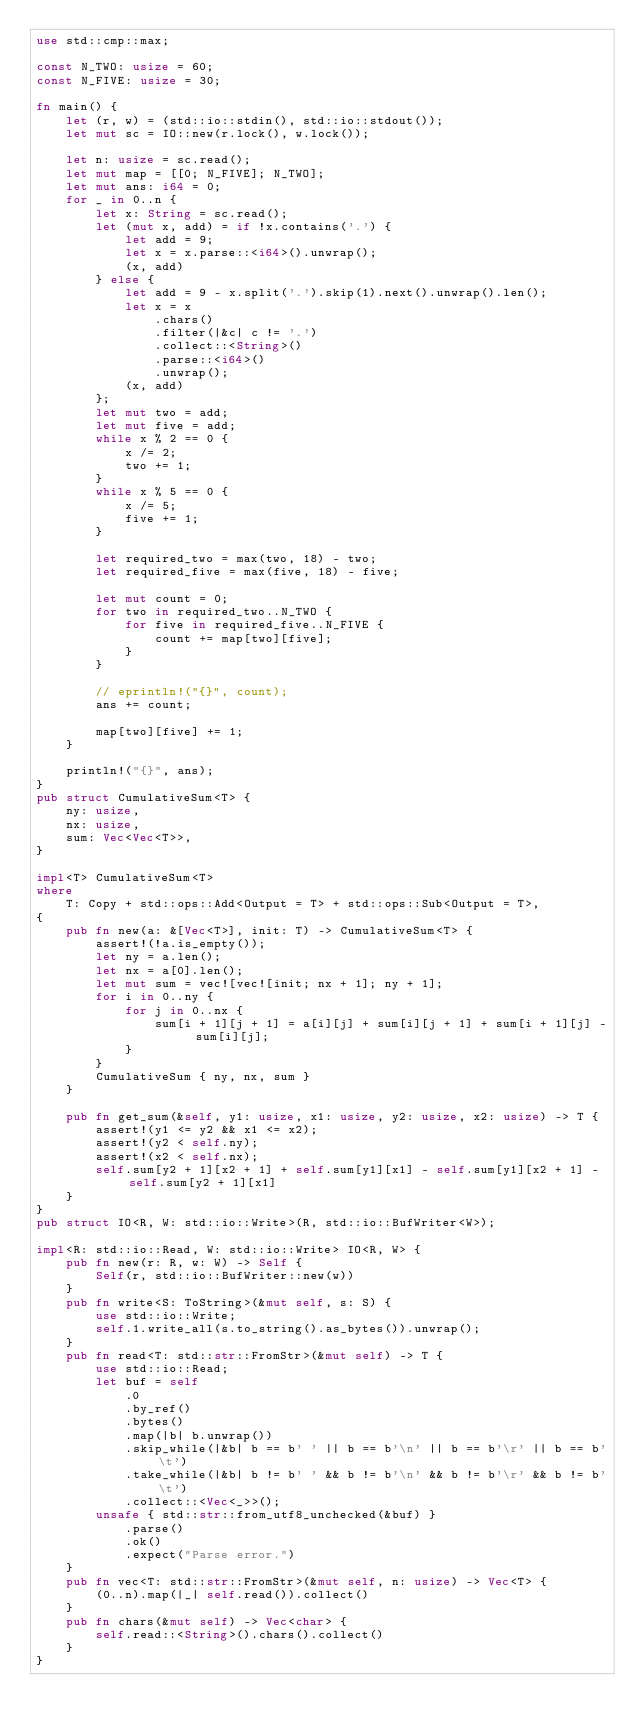Convert code to text. <code><loc_0><loc_0><loc_500><loc_500><_Rust_>use std::cmp::max;

const N_TWO: usize = 60;
const N_FIVE: usize = 30;

fn main() {
    let (r, w) = (std::io::stdin(), std::io::stdout());
    let mut sc = IO::new(r.lock(), w.lock());

    let n: usize = sc.read();
    let mut map = [[0; N_FIVE]; N_TWO];
    let mut ans: i64 = 0;
    for _ in 0..n {
        let x: String = sc.read();
        let (mut x, add) = if !x.contains('.') {
            let add = 9;
            let x = x.parse::<i64>().unwrap();
            (x, add)
        } else {
            let add = 9 - x.split('.').skip(1).next().unwrap().len();
            let x = x
                .chars()
                .filter(|&c| c != '.')
                .collect::<String>()
                .parse::<i64>()
                .unwrap();
            (x, add)
        };
        let mut two = add;
        let mut five = add;
        while x % 2 == 0 {
            x /= 2;
            two += 1;
        }
        while x % 5 == 0 {
            x /= 5;
            five += 1;
        }

        let required_two = max(two, 18) - two;
        let required_five = max(five, 18) - five;

        let mut count = 0;
        for two in required_two..N_TWO {
            for five in required_five..N_FIVE {
                count += map[two][five];
            }
        }

        // eprintln!("{}", count);
        ans += count;

        map[two][five] += 1;
    }

    println!("{}", ans);
}
pub struct CumulativeSum<T> {
    ny: usize,
    nx: usize,
    sum: Vec<Vec<T>>,
}

impl<T> CumulativeSum<T>
where
    T: Copy + std::ops::Add<Output = T> + std::ops::Sub<Output = T>,
{
    pub fn new(a: &[Vec<T>], init: T) -> CumulativeSum<T> {
        assert!(!a.is_empty());
        let ny = a.len();
        let nx = a[0].len();
        let mut sum = vec![vec![init; nx + 1]; ny + 1];
        for i in 0..ny {
            for j in 0..nx {
                sum[i + 1][j + 1] = a[i][j] + sum[i][j + 1] + sum[i + 1][j] - sum[i][j];
            }
        }
        CumulativeSum { ny, nx, sum }
    }

    pub fn get_sum(&self, y1: usize, x1: usize, y2: usize, x2: usize) -> T {
        assert!(y1 <= y2 && x1 <= x2);
        assert!(y2 < self.ny);
        assert!(x2 < self.nx);
        self.sum[y2 + 1][x2 + 1] + self.sum[y1][x1] - self.sum[y1][x2 + 1] - self.sum[y2 + 1][x1]
    }
}
pub struct IO<R, W: std::io::Write>(R, std::io::BufWriter<W>);

impl<R: std::io::Read, W: std::io::Write> IO<R, W> {
    pub fn new(r: R, w: W) -> Self {
        Self(r, std::io::BufWriter::new(w))
    }
    pub fn write<S: ToString>(&mut self, s: S) {
        use std::io::Write;
        self.1.write_all(s.to_string().as_bytes()).unwrap();
    }
    pub fn read<T: std::str::FromStr>(&mut self) -> T {
        use std::io::Read;
        let buf = self
            .0
            .by_ref()
            .bytes()
            .map(|b| b.unwrap())
            .skip_while(|&b| b == b' ' || b == b'\n' || b == b'\r' || b == b'\t')
            .take_while(|&b| b != b' ' && b != b'\n' && b != b'\r' && b != b'\t')
            .collect::<Vec<_>>();
        unsafe { std::str::from_utf8_unchecked(&buf) }
            .parse()
            .ok()
            .expect("Parse error.")
    }
    pub fn vec<T: std::str::FromStr>(&mut self, n: usize) -> Vec<T> {
        (0..n).map(|_| self.read()).collect()
    }
    pub fn chars(&mut self) -> Vec<char> {
        self.read::<String>().chars().collect()
    }
}
</code> 